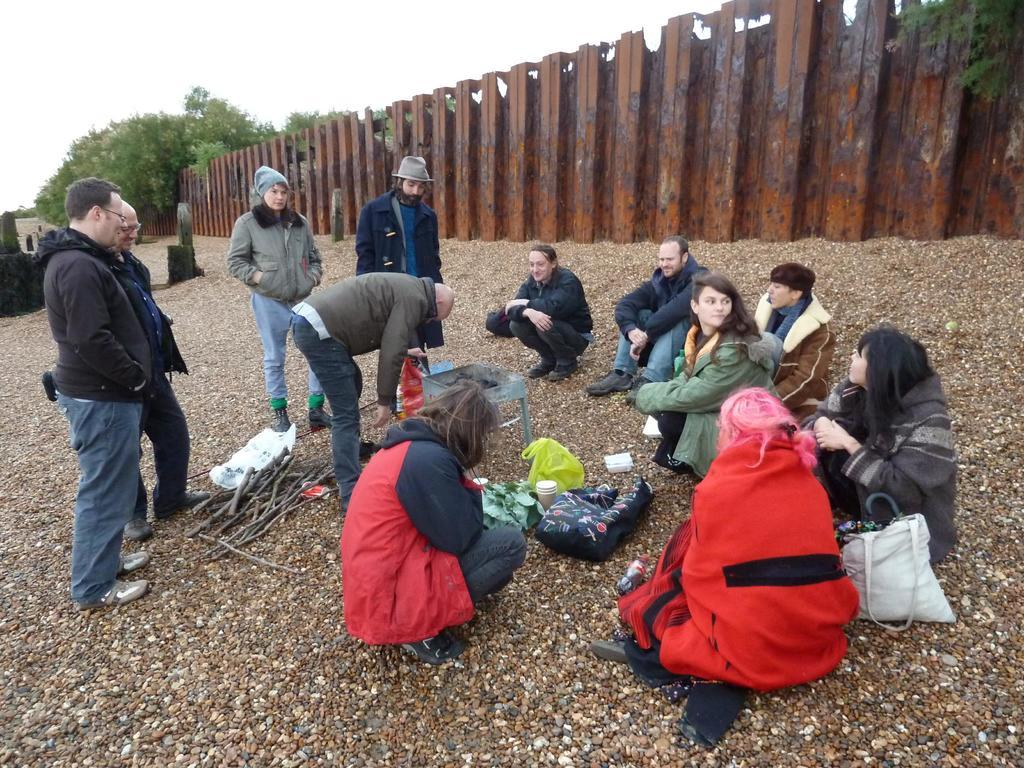How many people are in the image? There are a few people in the image. What is covering the ground in the image? The ground is covered with wooden sticks and a bag. What type of barrier can be seen in the image? There is a fence in the image. What type of natural elements are present in the image? There are trees in the image. What part of the natural environment is visible in the image? The sky is visible in the image. What type of pie is being served to the people in the image? There is no pie present in the image; it features a few people, a fence, trees, and the sky. What type of dress is the tree wearing in the image? Trees do not wear dresses; they are natural elements and do not have clothing. 